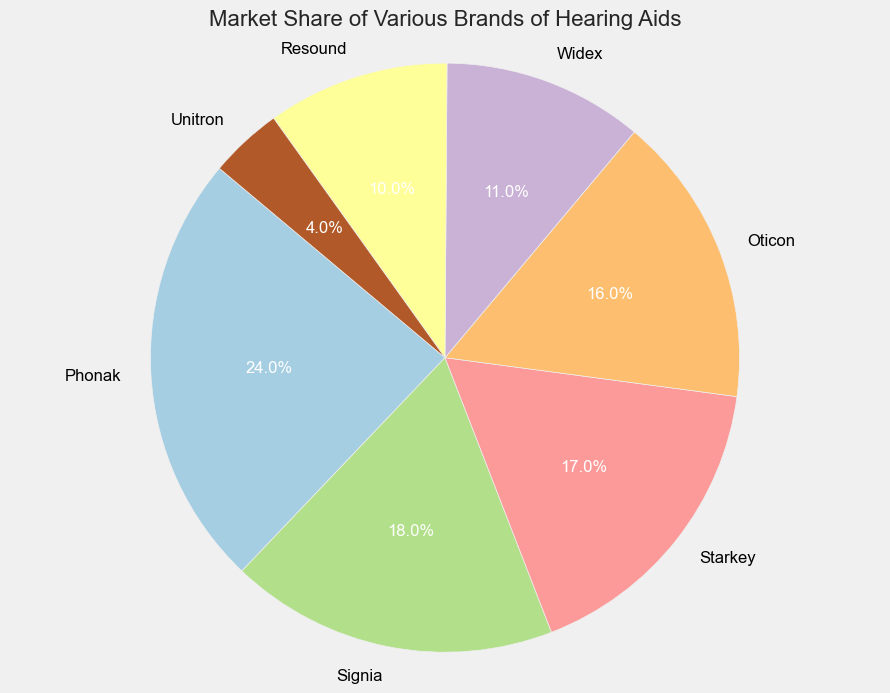What is the brand with the largest market share? By looking at the pie chart, the wedge for Phonak is the largest, indicating it has the highest market share.
Answer: Phonak Which brand has the smallest market share? By observing the pie chart, the smallest wedge corresponds to Unitron, meaning it has the smallest market share.
Answer: Unitron How much greater is the market share of Phonak compared to Starkey? Phonak has 24% market share and Starkey has 17%. The difference is 24% - 17% = 7%.
Answer: 7% What is the combined market share of Oticon and Widex? Oticon has a market share of 16% and Widex has 11%. Their combined market share is 16% + 11% = 27%.
Answer: 27% If you combine the market shares of the three brands with the smallest shares, what is their total market share? The three brands with the smallest shares are Unitron (4%), Resound (10%), and Widex (11%). Adding these gives 4% + 10% + 11% = 25%.
Answer: 25% Which brand has a market share closest to the median value of the given market shares? To find the median, list the market shares in ascending order: 4%, 10%, 11%, 16%, 17%, 18%, 24%. The median is 16%, which corresponds to Oticon.
Answer: Oticon What is the sum of the market shares of the brands with more than 15% market share? The brands with more than 15% market share are Phonak (24%), Signia (18%), and Starkey (17%). Their sum is 24% + 18% + 17% = 59%.
Answer: 59% How does the market share of Signia compare to that of Widex in terms of percentage points? Signia has a market share of 18% and Widex has 11%. The difference in percentage points is 18% - 11% = 7%.
Answer: 7% Among the given brands, which one has a market share color represented first in the color palette? In the pie chart, the first brand's wedge is colored first from the color palette, which is Phonak.
Answer: Phonak How many brands have a market share of more than 15%? By checking the values for each brand, Phonak, Signia, and Starkey each have more than 15% market share. There are 3 such brands.
Answer: 3 